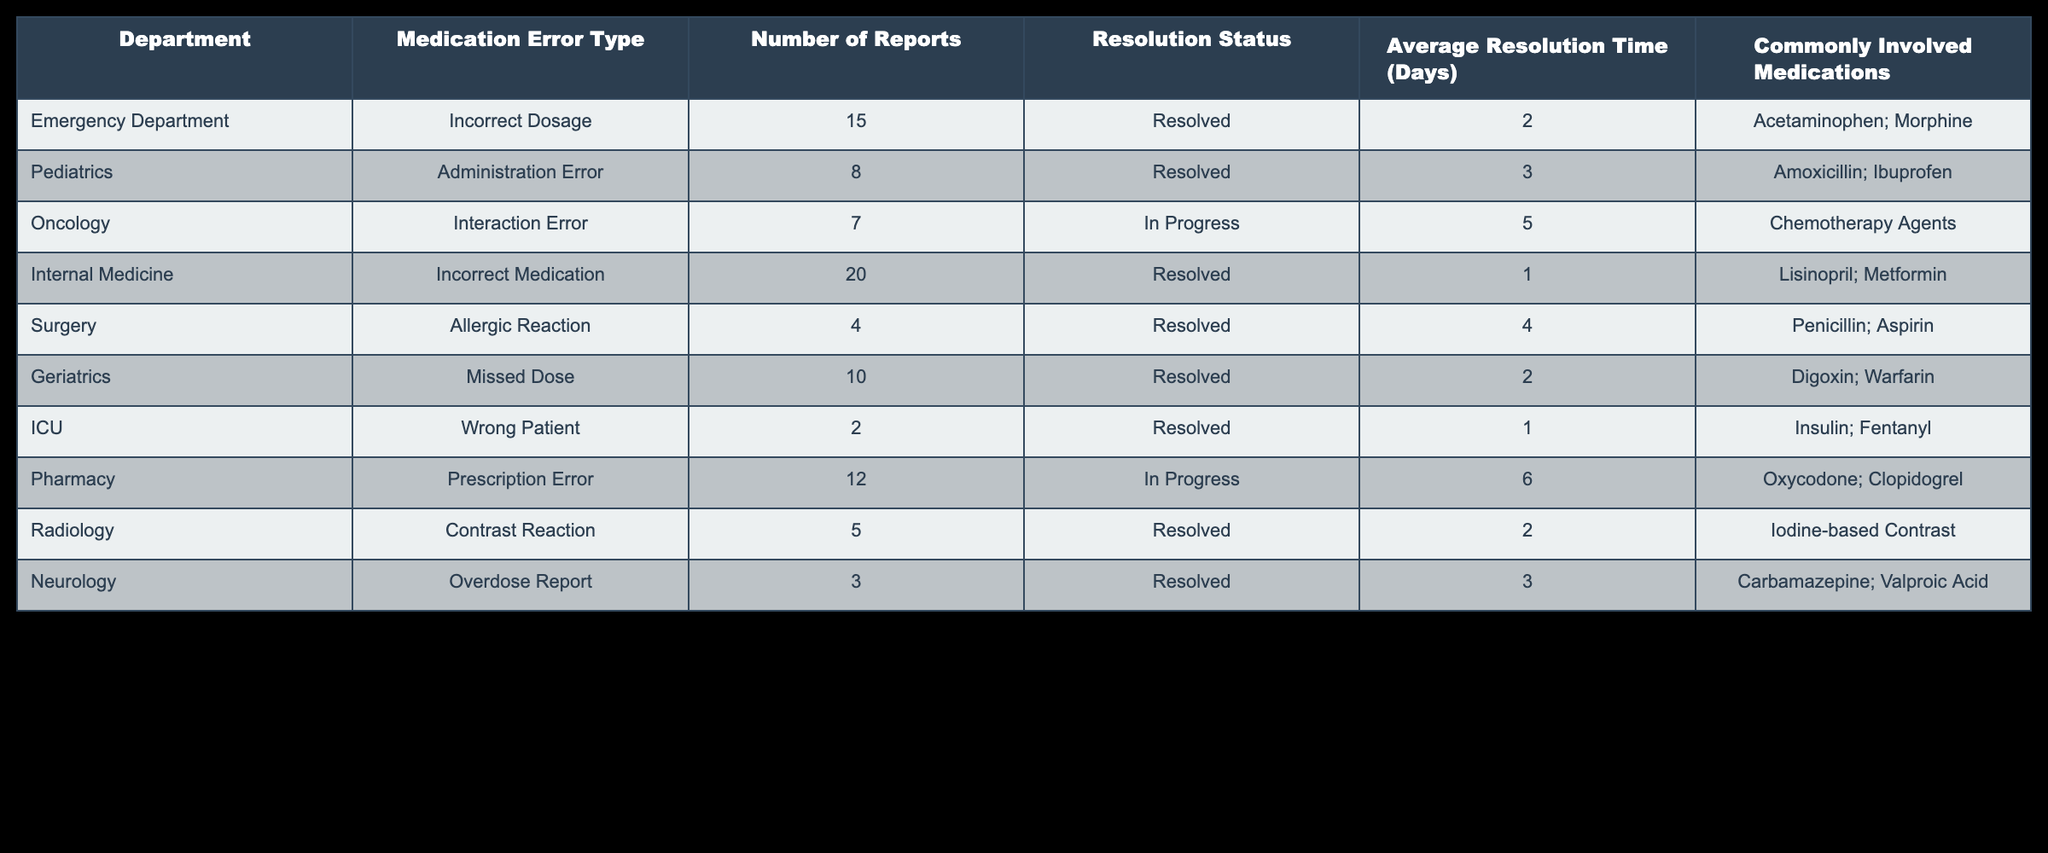What is the most common medication error type reported in the Internal Medicine department? According to the table, the most common medication error type in the Internal Medicine department is 'Incorrect Medication' with 20 reports.
Answer: Incorrect Medication Which department has the least number of medication error reports? The department with the least number of medication error reports is the ICU, with only 2 reports.
Answer: ICU What is the average resolution time for medication error reports in the Pediatrics department? The average resolution time for medication error reports in the Pediatrics department is 3 days, as listed in the table.
Answer: 3 days Are there any departments with medication reports still 'In Progress'? Yes, both the Oncology and Pharmacy departments have medication error reports that are 'In Progress'.
Answer: Yes What is the total number of resolved medication error reports across all departments? By summing the resolved reports from each department (15 + 8 + 20 + 4 + 10 + 2 + 5 + 3 = 67), we find that the total number of resolved medication error reports across all departments is 67.
Answer: 67 What is the average number of reports for departments not resolved? There are two departments with 'In Progress' status – Oncology with 7 reports and Pharmacy with 12 reports. Combining these gives a total of 19 reports. The average is calculated as 19 reports divided by 2 departments, resulting in an average of 9.5.
Answer: 9.5 Which department reports the highest average resolution time? Looking at the table, the Pharmacy department has the highest average resolution time of 6 days for its medication error reports that are still 'In Progress'.
Answer: 6 days Is it true that all departments except for Oncology and Pharmacy have resolved their reports within 5 days? Yes, all departments except for Oncology and Pharmacy (which has an average resolution time of 5 days and still has reports 'In Progress') have resolved their reports within 5 days.
Answer: Yes How many commonly involved medications were listed for the Surgery department? The Surgery department has two commonly involved medications: Penicillin and Aspirin, listed in the table.
Answer: 2 